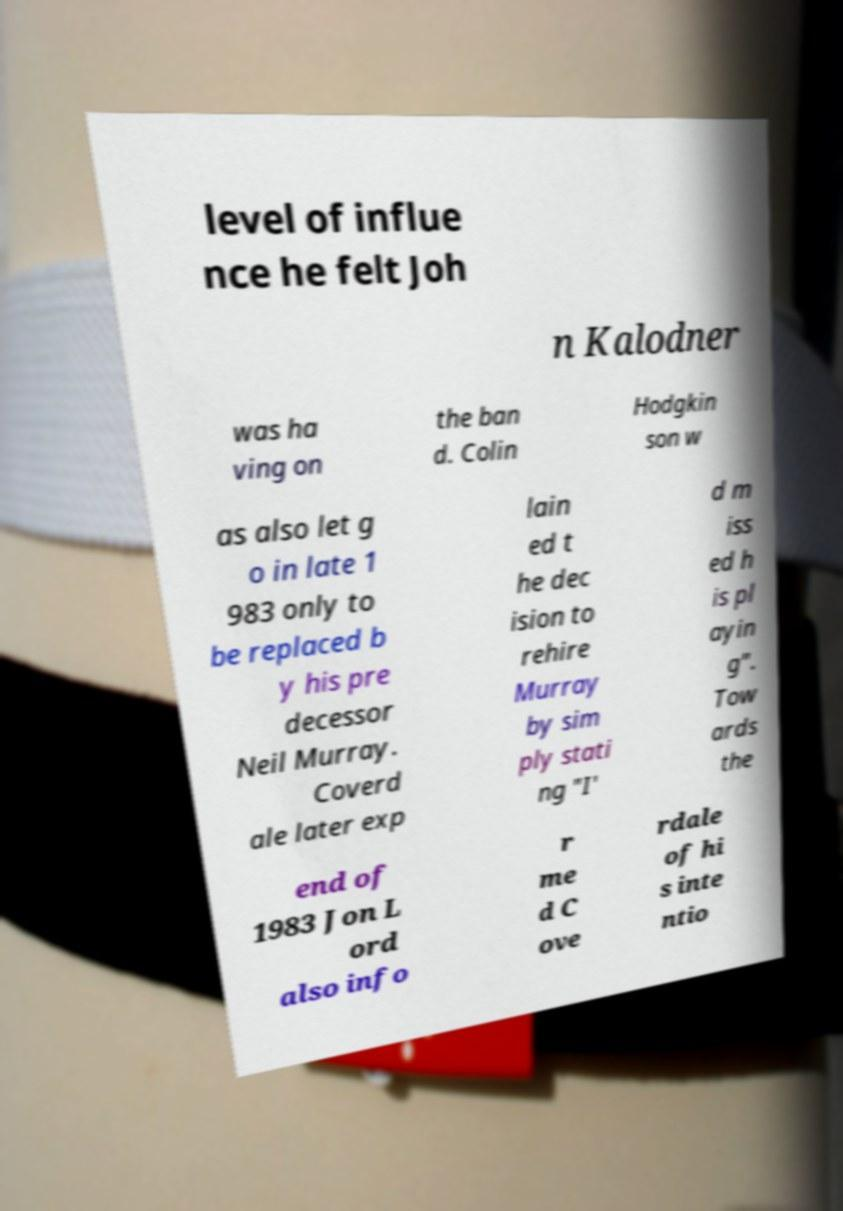Please read and relay the text visible in this image. What does it say? level of influe nce he felt Joh n Kalodner was ha ving on the ban d. Colin Hodgkin son w as also let g o in late 1 983 only to be replaced b y his pre decessor Neil Murray. Coverd ale later exp lain ed t he dec ision to rehire Murray by sim ply stati ng "I' d m iss ed h is pl ayin g". Tow ards the end of 1983 Jon L ord also info r me d C ove rdale of hi s inte ntio 